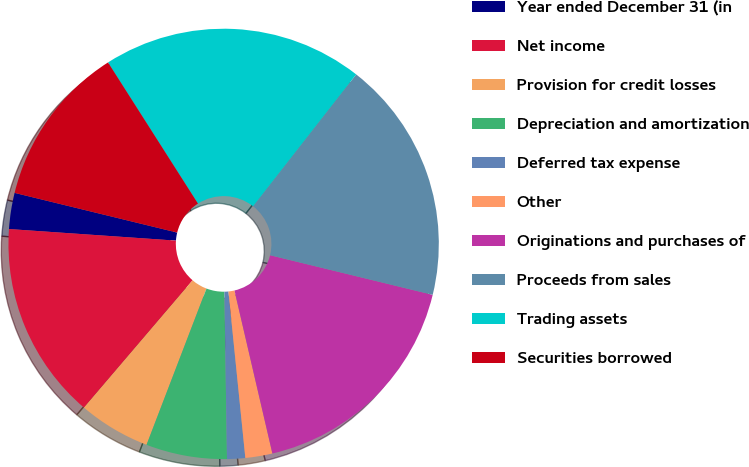Convert chart to OTSL. <chart><loc_0><loc_0><loc_500><loc_500><pie_chart><fcel>Year ended December 31 (in<fcel>Net income<fcel>Provision for credit losses<fcel>Depreciation and amortization<fcel>Deferred tax expense<fcel>Other<fcel>Originations and purchases of<fcel>Proceeds from sales<fcel>Trading assets<fcel>Securities borrowed<nl><fcel>2.71%<fcel>14.86%<fcel>5.41%<fcel>6.08%<fcel>1.36%<fcel>2.03%<fcel>17.56%<fcel>18.24%<fcel>19.59%<fcel>12.16%<nl></chart> 